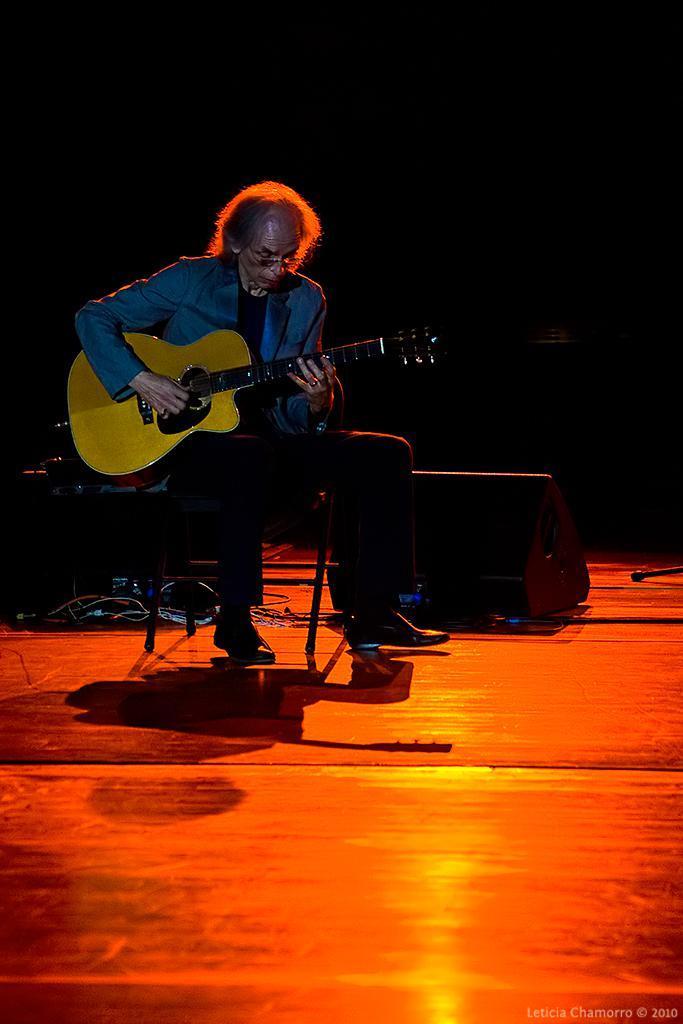How would you summarize this image in a sentence or two? In this picture there is a man sitting in the chair and playing a guitar in his hands on the stage. Behind him there is a box placed. In the background there is dark. 